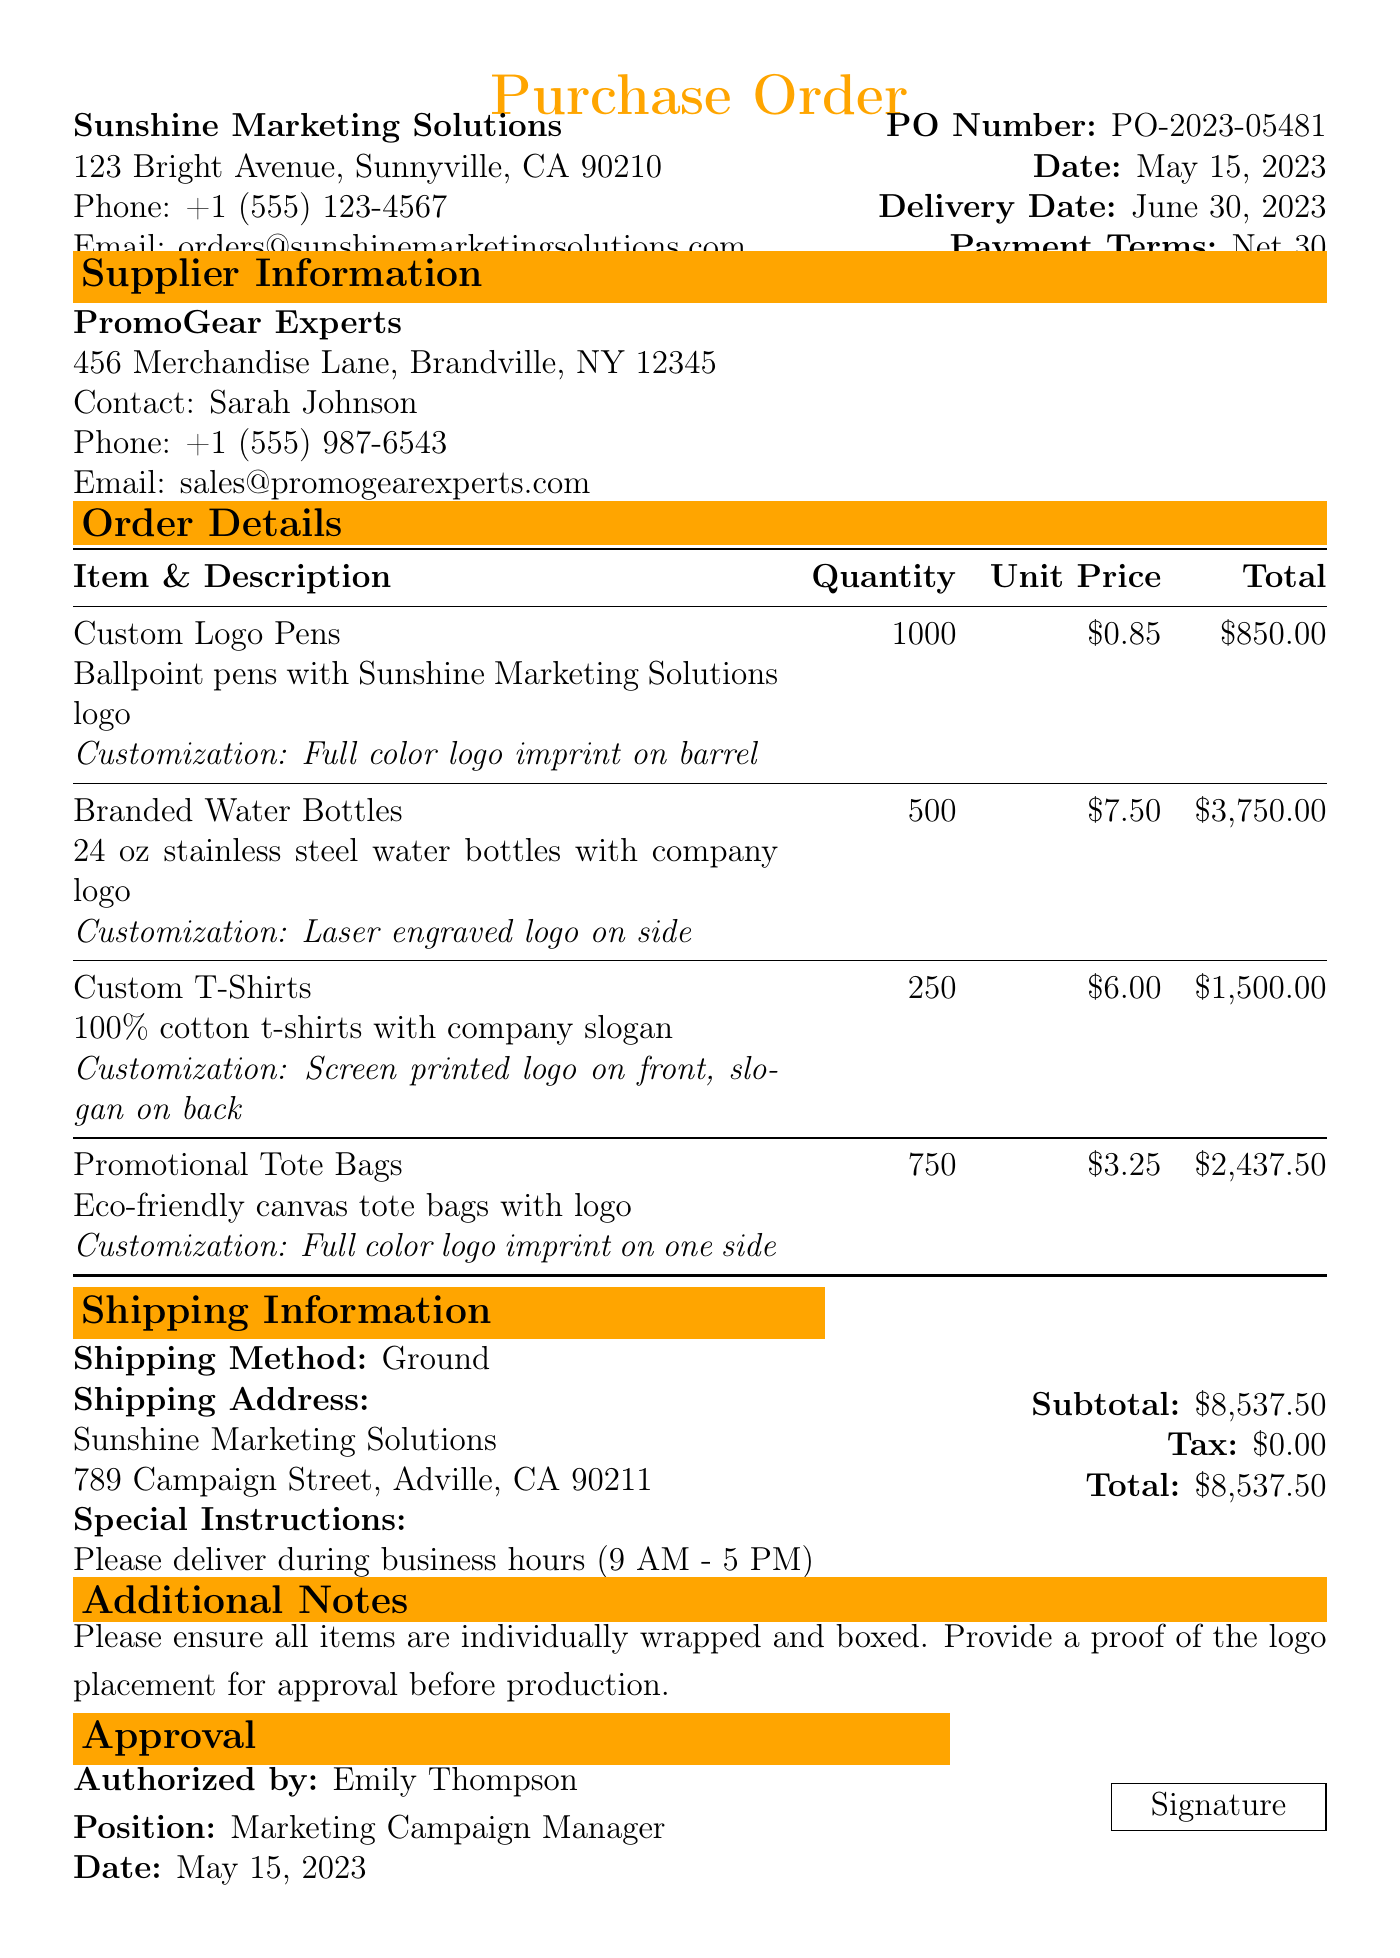What is the PO number? The PO number is specified in the purchase order section of the document.
Answer: PO-2023-05481 Who is the contact person for the supplier? The contact person is mentioned under the supplier information section.
Answer: Sarah Johnson What is the total amount of the order? The total amount is calculated from the item totals listed in the document.
Answer: 8537.50 How many Custom T-Shirts are ordered? The quantity of Custom T-Shirts is specified in the order details section.
Answer: 250 What is the delivery date for the purchase order? The delivery date is stated in the purchase order section.
Answer: June 30, 2023 What is the customization for the Branded Water Bottles? The customization details for the Branded Water Bottles are listed in the respective item description.
Answer: Laser engraved logo on side What shipping method is being used? The shipping information section outlines the method of shipping for the order.
Answer: Ground Who authorized the purchase order? The authorized individual is mentioned in the approval section of the document.
Answer: Emily Thompson How many Promotional Tote Bags are included in the order? The number of Promotional Tote Bags is found in the item quantities listed in the document.
Answer: 750 